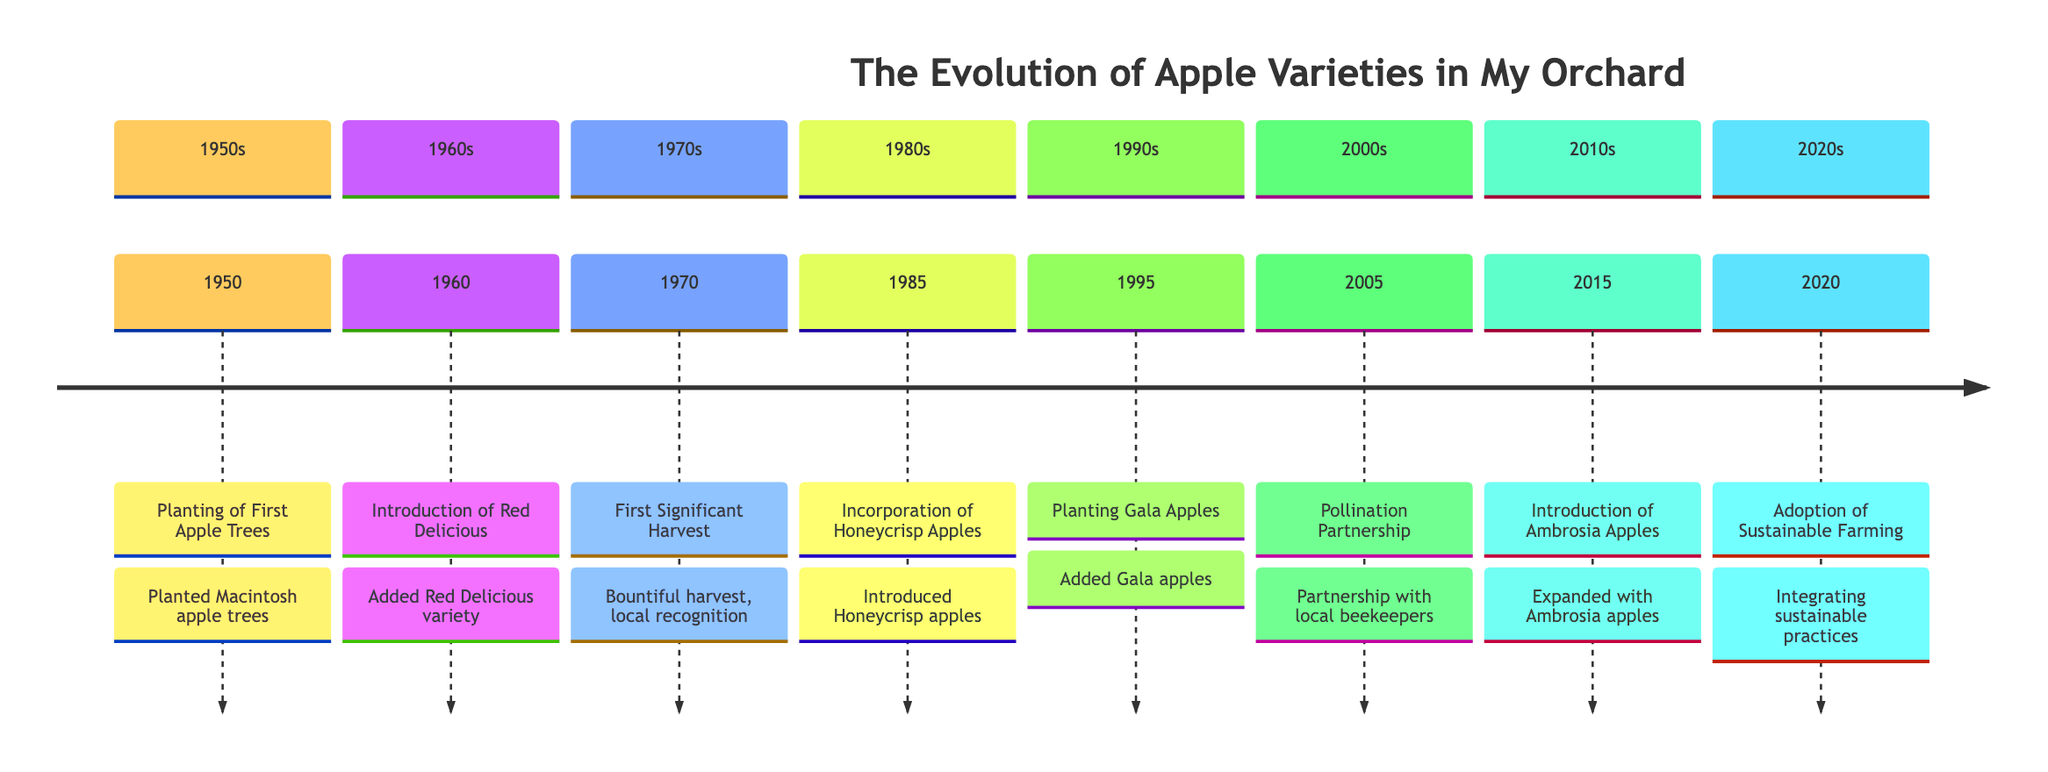What year were Honeycrisp apples introduced? The timeline indicates that Honeycrisp apples were introduced in 1985, as noted in that specific section.
Answer: 1985 What was the first apple variety planted in the orchard? According to the first event in the timeline, the first apple variety planted in the orchard was Macintosh.
Answer: Macintosh How many apple varieties are added to the orchard by 2015? By 2015, five distinct apple varieties (Macintosh, Red Delicious, Honeycrisp, Gala, and Ambrosia) are mentioned in the timeline.
Answer: 5 In which year did the orchard experience its first significant harvest? The timeline specifies that the first significant harvest occurred in 1970, marked in that section.
Answer: 1970 What partnership was established in 2005? The timeline reveals a "Pollination Partnership" with local beekeepers was established in 2005 to enhance pollination.
Answer: Pollination Partnership What major practice was adopted in 2020? The timeline states that in 2020, sustainable farming practices were adopted, which is clearly indicated in that year’s entry.
Answer: Sustainable farming practices Which apple variety is noted for its balanced flavor and high yield? The timeline specifies that Gala apples are recognized for their balanced flavor and high yield, as stated in the corresponding year.
Answer: Gala apples In what decade did the introduction of Ambrosia apples occur? The timeline indicates that Ambrosia apples were introduced in the 2010s, as noted beside the year 2015.
Answer: 2010s What event led to local recognition of the orchard? The first significant harvest in 1970 is noted to have led to local recognition, clearly stated in that event.
Answer: First Significant Harvest 